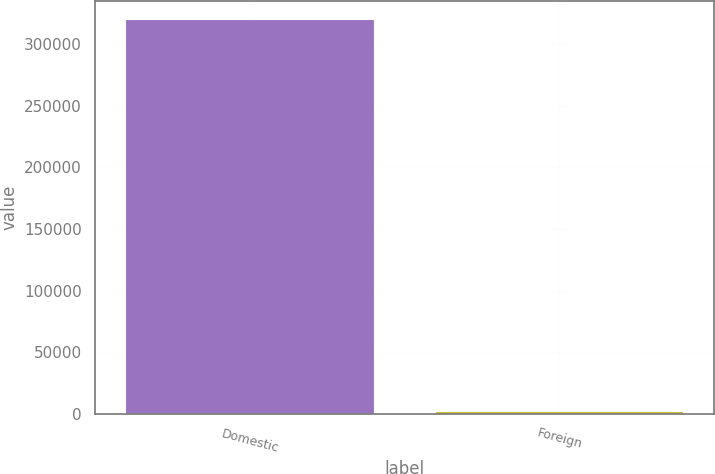<chart> <loc_0><loc_0><loc_500><loc_500><bar_chart><fcel>Domestic<fcel>Foreign<nl><fcel>319494<fcel>1535<nl></chart> 